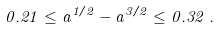<formula> <loc_0><loc_0><loc_500><loc_500>0 . 2 1 \leq a ^ { 1 / 2 } - a ^ { 3 / 2 } \leq 0 . 3 2 \, .</formula> 